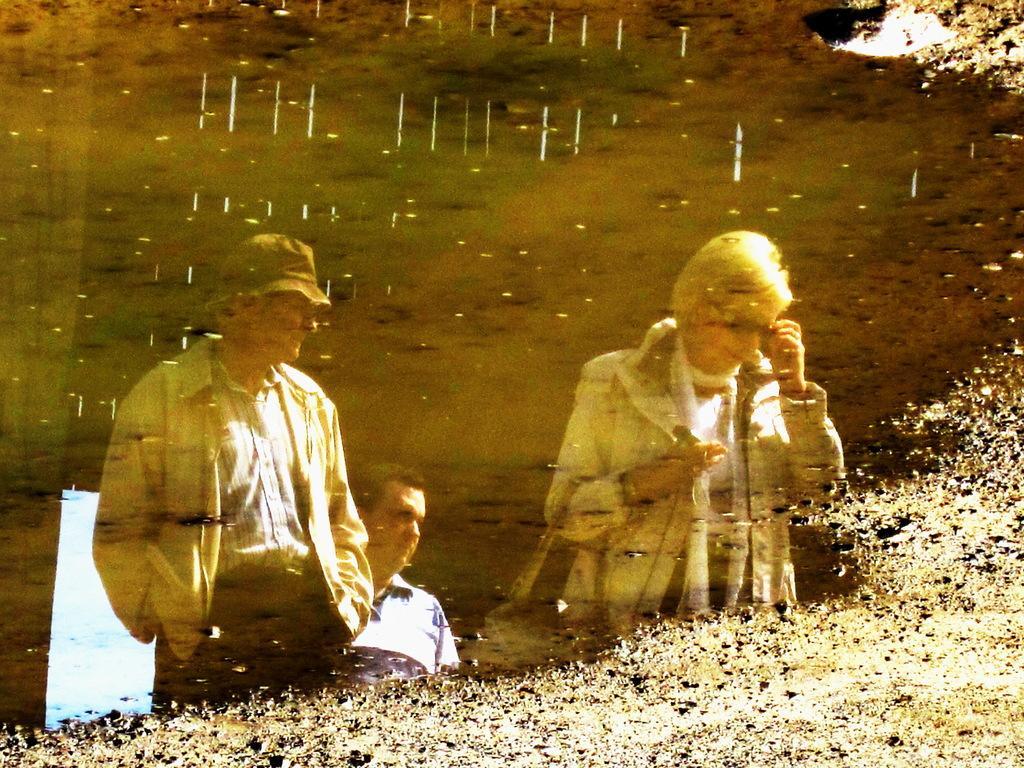How would you summarize this image in a sentence or two? Here in this picture we can see water present on the ground and in that we can see reflection of a group of people standing over a place and the man is wearing a hat and the woman is carrying a bag and wearing spectacles. 